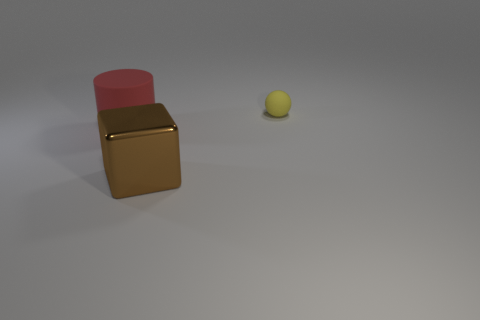Add 3 red rubber cylinders. How many objects exist? 6 Subtract all balls. How many objects are left? 2 Add 2 brown cubes. How many brown cubes exist? 3 Subtract 0 brown cylinders. How many objects are left? 3 Subtract all big purple objects. Subtract all big metallic cubes. How many objects are left? 2 Add 1 red things. How many red things are left? 2 